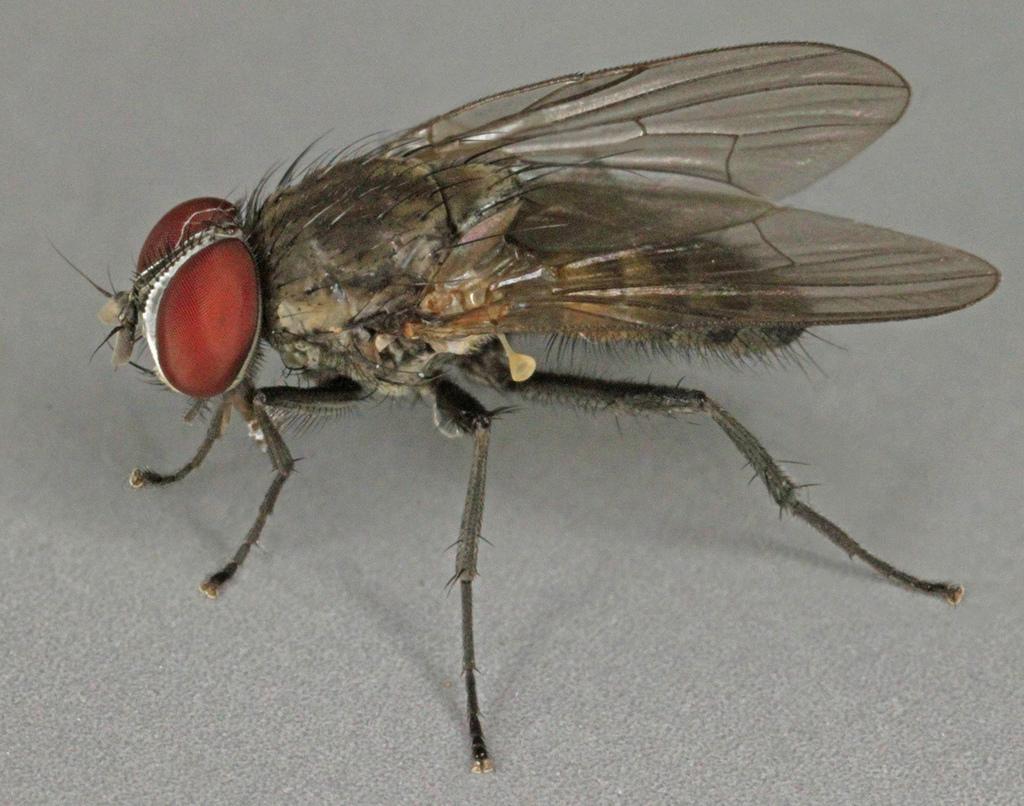Describe this image in one or two sentences. It is a closed picture of a fly on the surface. 